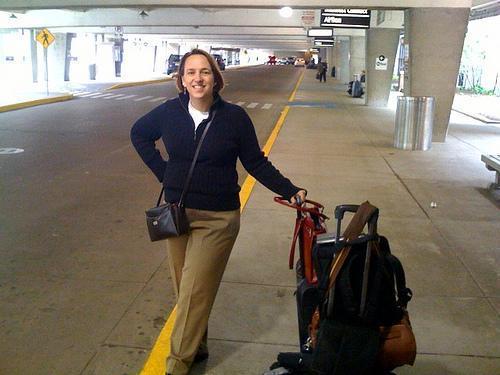How many people are there?
Give a very brief answer. 1. How many animals are there?
Give a very brief answer. 0. How many people are in the picture?
Give a very brief answer. 1. How many handbags are there?
Give a very brief answer. 1. How many black horses are there?
Give a very brief answer. 0. 